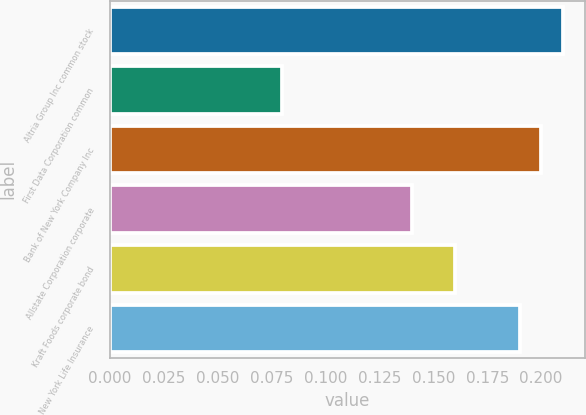Convert chart. <chart><loc_0><loc_0><loc_500><loc_500><bar_chart><fcel>Altria Group Inc common stock<fcel>First Data Corporation common<fcel>Bank of New York Company Inc<fcel>Allstate Corporation corporate<fcel>Kraft Foods corporate bond<fcel>New York Life Insurance<nl><fcel>0.21<fcel>0.08<fcel>0.2<fcel>0.14<fcel>0.16<fcel>0.19<nl></chart> 